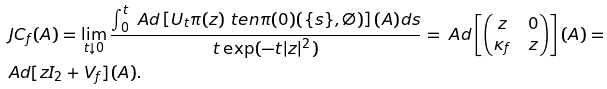Convert formula to latex. <formula><loc_0><loc_0><loc_500><loc_500>& \ J C _ { f } ( A ) = \lim _ { t \downarrow 0 } \frac { \int _ { 0 } ^ { t } \ A d \left [ U _ { t } \pi ( z ) \ t e n \pi ( 0 ) ( \{ s \} , \emptyset ) \right ] ( A ) d s } { t \exp ( - t | z | ^ { 2 } ) } = \ A d \left [ \begin{pmatrix} z & 0 \\ \kappa _ { f } & z \end{pmatrix} \right ] ( A ) = \\ & \ A d [ z I _ { 2 } + V _ { f } ] ( A ) .</formula> 